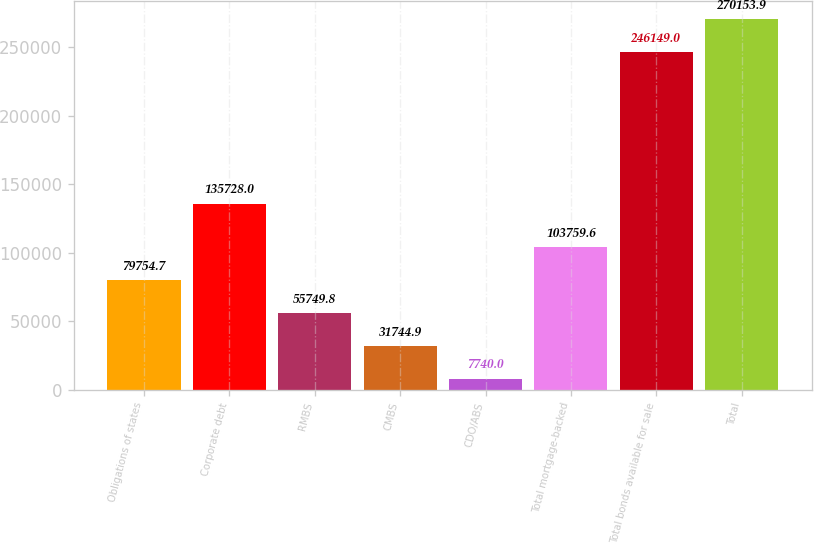Convert chart to OTSL. <chart><loc_0><loc_0><loc_500><loc_500><bar_chart><fcel>Obligations of states<fcel>Corporate debt<fcel>RMBS<fcel>CMBS<fcel>CDO/ABS<fcel>Total mortgage-backed<fcel>Total bonds available for sale<fcel>Total<nl><fcel>79754.7<fcel>135728<fcel>55749.8<fcel>31744.9<fcel>7740<fcel>103760<fcel>246149<fcel>270154<nl></chart> 